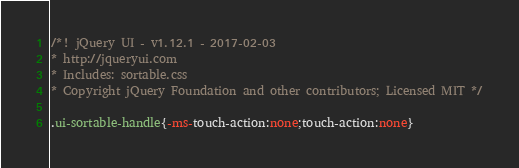<code> <loc_0><loc_0><loc_500><loc_500><_CSS_>/*! jQuery UI - v1.12.1 - 2017-02-03
* http://jqueryui.com
* Includes: sortable.css
* Copyright jQuery Foundation and other contributors; Licensed MIT */

.ui-sortable-handle{-ms-touch-action:none;touch-action:none}</code> 